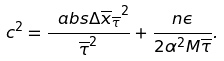<formula> <loc_0><loc_0><loc_500><loc_500>c ^ { 2 } = \frac { \ a b s { \Delta \overline { x } _ { \overline { \tau } } } ^ { 2 } } { \overline { \tau } ^ { 2 } } + \frac { n \epsilon } { 2 \alpha ^ { 2 } M \overline { \tau } } .</formula> 